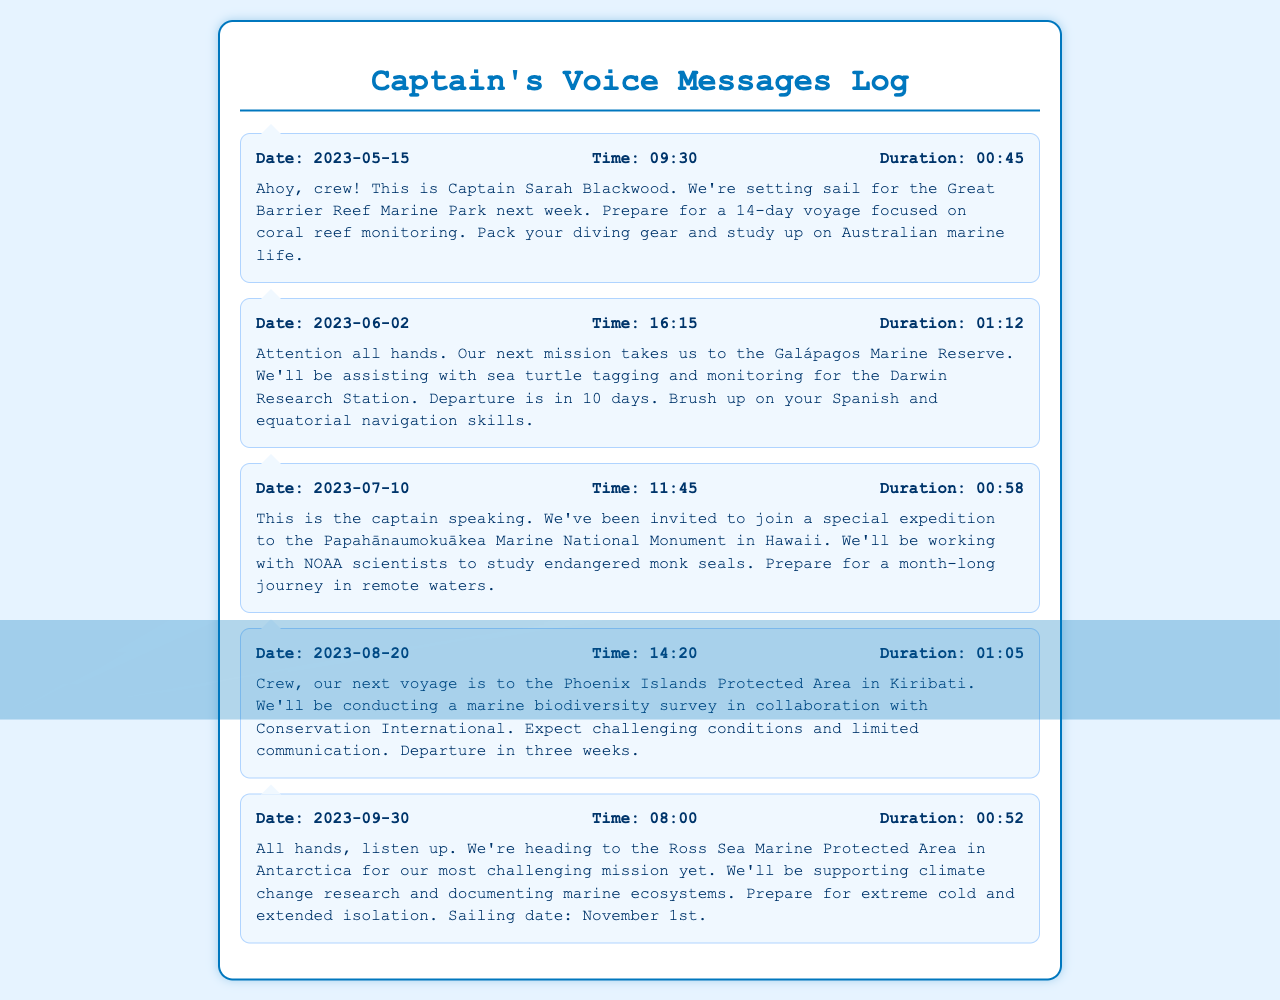What is the date of the first message? The first message is dated 2023-05-15.
Answer: 2023-05-15 What is the focus of the voyage to the Great Barrier Reef Marine Park? The Great Barrier Reef Marine Park voyage focuses on coral reef monitoring.
Answer: coral reef monitoring How long is the voyage to the Papahānaumokuākea Marine National Monument? The voyage to the Papahānaumokuākea Marine National Monument is a month-long journey.
Answer: a month-long journey What type of research will be conducted in the Ross Sea Marine Protected Area? The research in the Ross Sea Marine Protected Area will support climate change research.
Answer: climate change research When is the departure for the mission to the Galápagos Marine Reserve? The departure for the Galápagos Marine Reserve mission is in 10 days from the message date.
Answer: in 10 days Who are the collaborators for the survey in the Phoenix Islands Protected Area? The collaborators for the survey in the Phoenix Islands Protected Area are Conservation International.
Answer: Conservation International What specific animals will be tagged during the Galápagos Marine Reserve mission? The animals being tagged during the Galápagos mission are sea turtles.
Answer: sea turtles What type of skills should crew members brush up on for the Galápagos mission? Crew members should brush up on their Spanish and equatorial navigation skills.
Answer: Spanish and equatorial navigation skills 